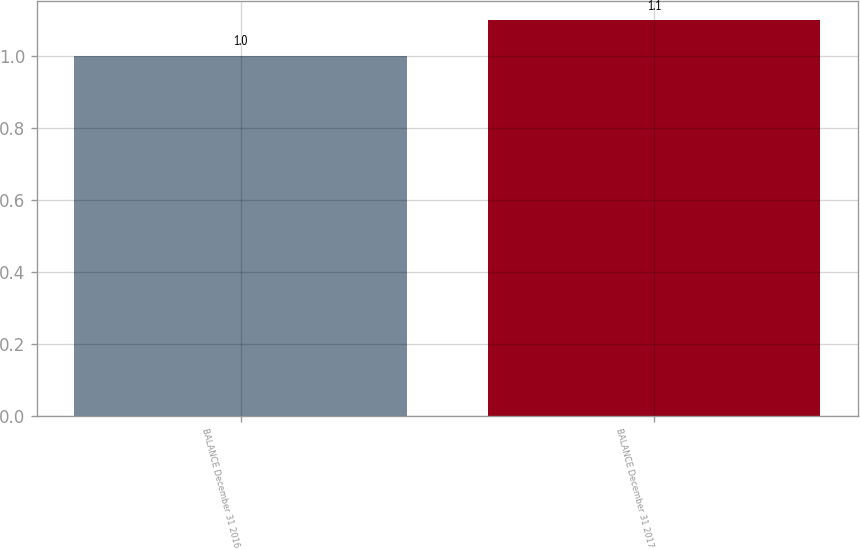Convert chart to OTSL. <chart><loc_0><loc_0><loc_500><loc_500><bar_chart><fcel>BALANCE December 31 2016<fcel>BALANCE December 31 2017<nl><fcel>1<fcel>1.1<nl></chart> 